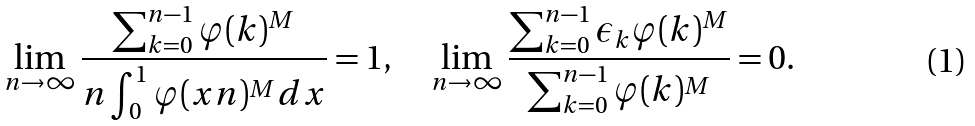<formula> <loc_0><loc_0><loc_500><loc_500>\lim _ { n \to \infty } \frac { \sum _ { k = 0 } ^ { n - 1 } \varphi ( k ) ^ { M } } { n \int _ { 0 } ^ { 1 } \varphi ( x n ) ^ { M } d x } = 1 , \quad \lim _ { n \to \infty } \frac { \sum _ { k = 0 } ^ { n - 1 } \epsilon _ { k } \varphi ( k ) ^ { M } } { \sum _ { k = 0 } ^ { n - 1 } \varphi ( k ) ^ { M } } = 0 .</formula> 